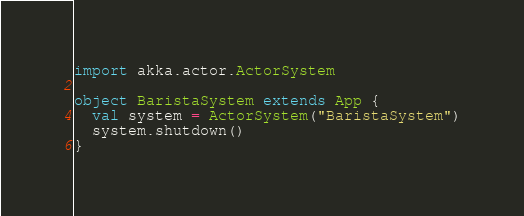Convert code to text. <code><loc_0><loc_0><loc_500><loc_500><_Scala_>import akka.actor.ActorSystem

object BaristaSystem extends App {
  val system = ActorSystem("BaristaSystem")
  system.shutdown()
}


</code> 